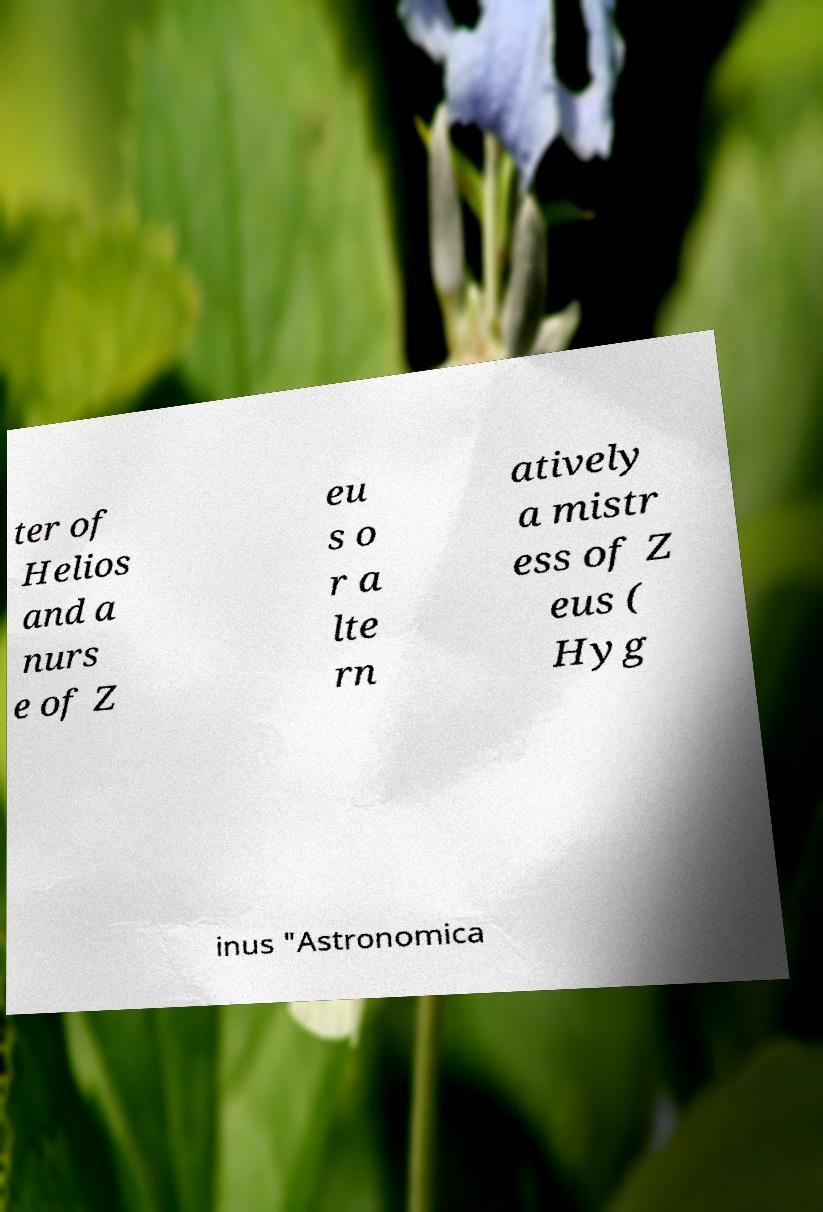There's text embedded in this image that I need extracted. Can you transcribe it verbatim? ter of Helios and a nurs e of Z eu s o r a lte rn atively a mistr ess of Z eus ( Hyg inus "Astronomica 